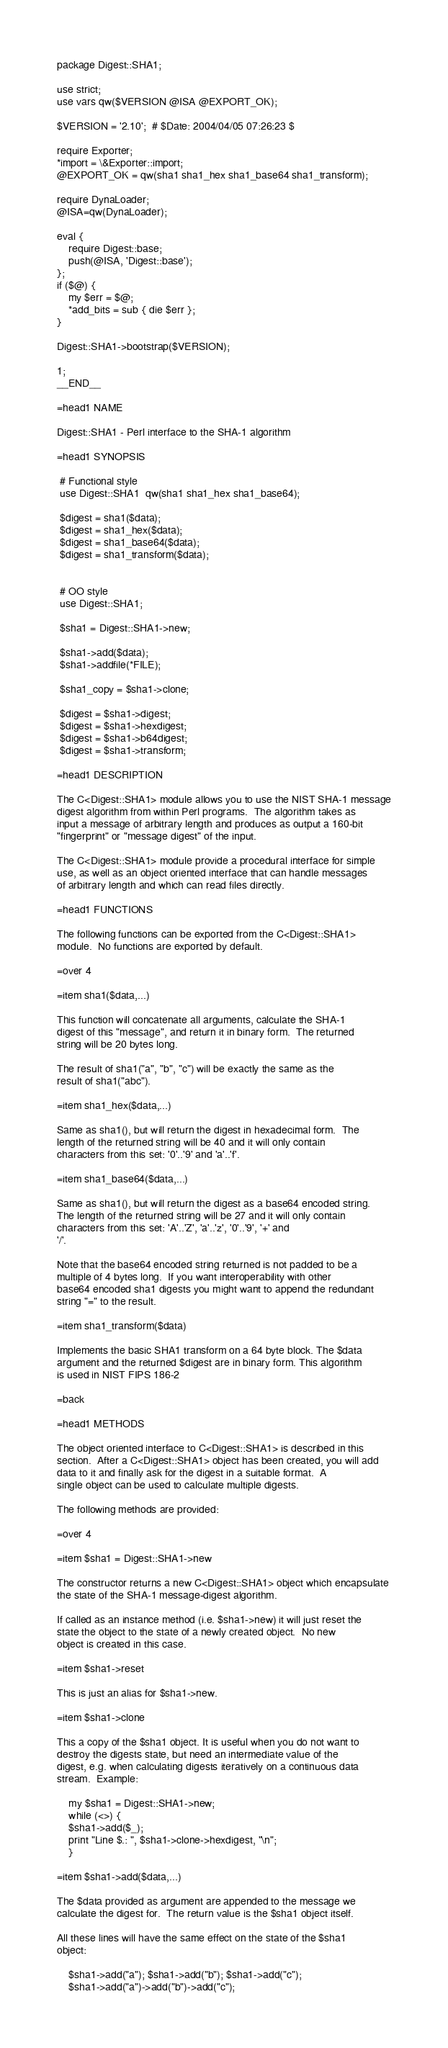Convert code to text. <code><loc_0><loc_0><loc_500><loc_500><_Perl_>package Digest::SHA1;

use strict;
use vars qw($VERSION @ISA @EXPORT_OK);

$VERSION = '2.10';  # $Date: 2004/04/05 07:26:23 $

require Exporter;
*import = \&Exporter::import;
@EXPORT_OK = qw(sha1 sha1_hex sha1_base64 sha1_transform);

require DynaLoader;
@ISA=qw(DynaLoader);

eval {
    require Digest::base;
    push(@ISA, 'Digest::base');
};
if ($@) {
    my $err = $@;
    *add_bits = sub { die $err };
}

Digest::SHA1->bootstrap($VERSION);

1;
__END__

=head1 NAME

Digest::SHA1 - Perl interface to the SHA-1 algorithm

=head1 SYNOPSIS

 # Functional style
 use Digest::SHA1  qw(sha1 sha1_hex sha1_base64);

 $digest = sha1($data);
 $digest = sha1_hex($data);
 $digest = sha1_base64($data);
 $digest = sha1_transform($data);


 # OO style
 use Digest::SHA1;

 $sha1 = Digest::SHA1->new;

 $sha1->add($data);
 $sha1->addfile(*FILE);

 $sha1_copy = $sha1->clone;

 $digest = $sha1->digest;
 $digest = $sha1->hexdigest;
 $digest = $sha1->b64digest;
 $digest = $sha1->transform;

=head1 DESCRIPTION

The C<Digest::SHA1> module allows you to use the NIST SHA-1 message
digest algorithm from within Perl programs.  The algorithm takes as
input a message of arbitrary length and produces as output a 160-bit
"fingerprint" or "message digest" of the input.

The C<Digest::SHA1> module provide a procedural interface for simple
use, as well as an object oriented interface that can handle messages
of arbitrary length and which can read files directly.

=head1 FUNCTIONS

The following functions can be exported from the C<Digest::SHA1>
module.  No functions are exported by default.

=over 4

=item sha1($data,...)

This function will concatenate all arguments, calculate the SHA-1
digest of this "message", and return it in binary form.  The returned
string will be 20 bytes long.

The result of sha1("a", "b", "c") will be exactly the same as the
result of sha1("abc").

=item sha1_hex($data,...)

Same as sha1(), but will return the digest in hexadecimal form.  The
length of the returned string will be 40 and it will only contain
characters from this set: '0'..'9' and 'a'..'f'.

=item sha1_base64($data,...)

Same as sha1(), but will return the digest as a base64 encoded string.
The length of the returned string will be 27 and it will only contain
characters from this set: 'A'..'Z', 'a'..'z', '0'..'9', '+' and
'/'.

Note that the base64 encoded string returned is not padded to be a
multiple of 4 bytes long.  If you want interoperability with other
base64 encoded sha1 digests you might want to append the redundant
string "=" to the result.

=item sha1_transform($data)

Implements the basic SHA1 transform on a 64 byte block. The $data
argument and the returned $digest are in binary form. This algorithm
is used in NIST FIPS 186-2

=back

=head1 METHODS

The object oriented interface to C<Digest::SHA1> is described in this
section.  After a C<Digest::SHA1> object has been created, you will add
data to it and finally ask for the digest in a suitable format.  A
single object can be used to calculate multiple digests.

The following methods are provided:

=over 4

=item $sha1 = Digest::SHA1->new

The constructor returns a new C<Digest::SHA1> object which encapsulate
the state of the SHA-1 message-digest algorithm.

If called as an instance method (i.e. $sha1->new) it will just reset the
state the object to the state of a newly created object.  No new
object is created in this case.

=item $sha1->reset

This is just an alias for $sha1->new.

=item $sha1->clone

This a copy of the $sha1 object. It is useful when you do not want to
destroy the digests state, but need an intermediate value of the
digest, e.g. when calculating digests iteratively on a continuous data
stream.  Example:

    my $sha1 = Digest::SHA1->new;
    while (<>) {
	$sha1->add($_);
	print "Line $.: ", $sha1->clone->hexdigest, "\n";
    }

=item $sha1->add($data,...)

The $data provided as argument are appended to the message we
calculate the digest for.  The return value is the $sha1 object itself.

All these lines will have the same effect on the state of the $sha1
object:

    $sha1->add("a"); $sha1->add("b"); $sha1->add("c");
    $sha1->add("a")->add("b")->add("c");</code> 